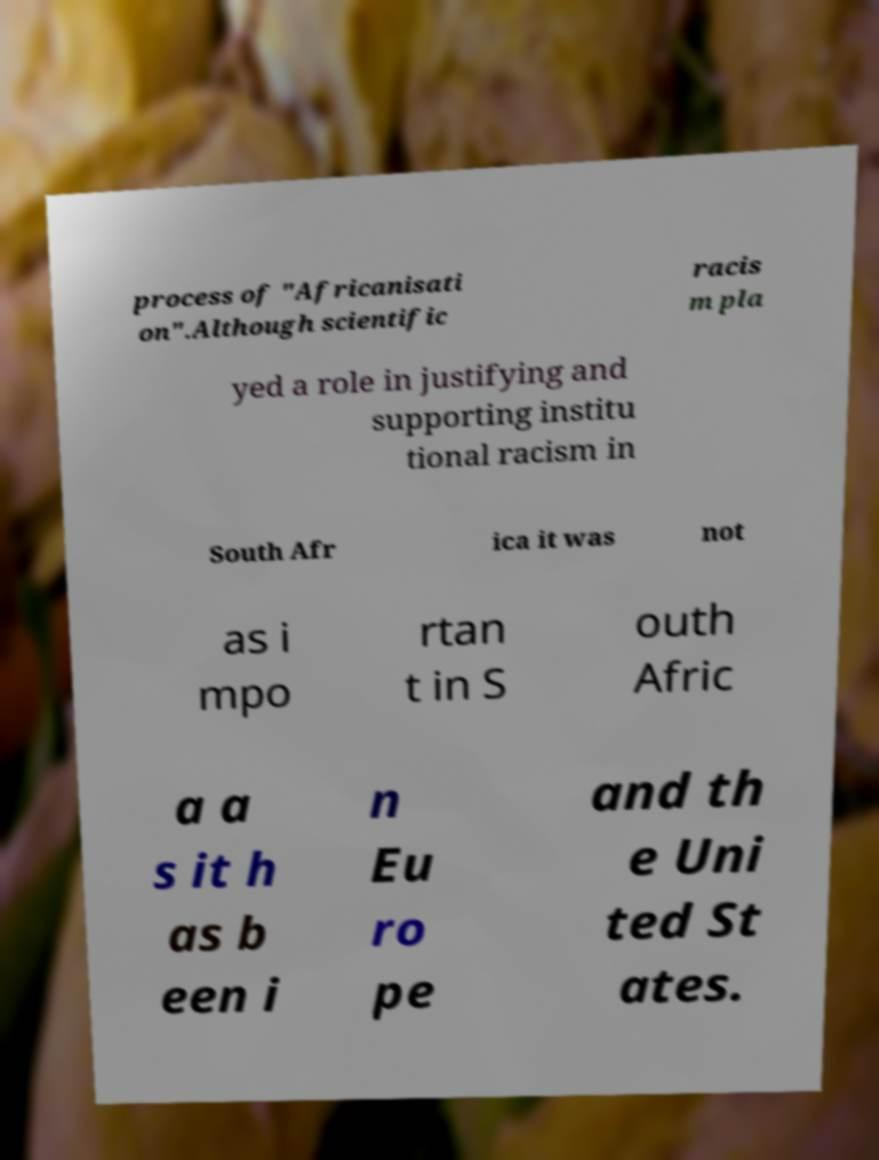Can you accurately transcribe the text from the provided image for me? process of "Africanisati on".Although scientific racis m pla yed a role in justifying and supporting institu tional racism in South Afr ica it was not as i mpo rtan t in S outh Afric a a s it h as b een i n Eu ro pe and th e Uni ted St ates. 